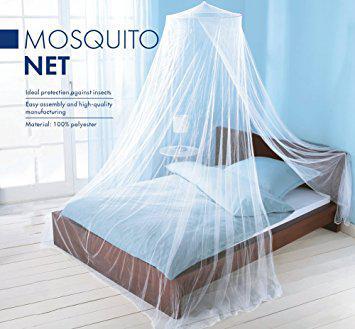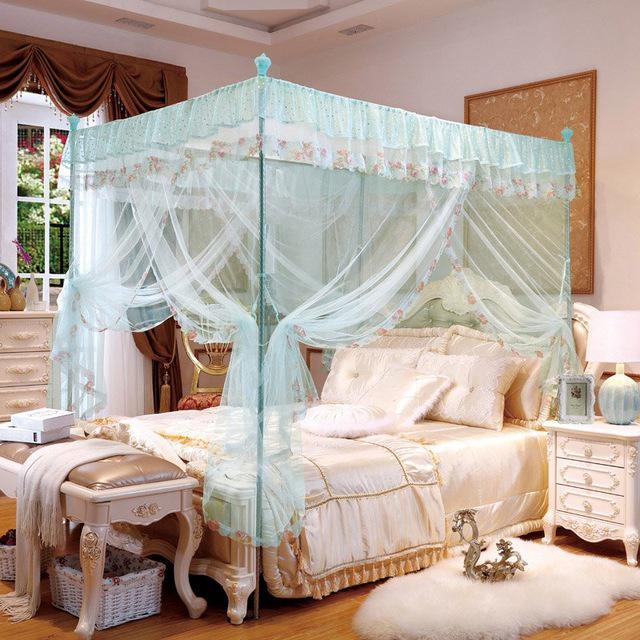The first image is the image on the left, the second image is the image on the right. Examine the images to the left and right. Is the description "The drapery of one bed frames it as a four poster with a top ruffle, while the other bed drapery falls from a central point above the bed." accurate? Answer yes or no. Yes. The first image is the image on the left, the second image is the image on the right. For the images shown, is this caption "An image shows a ceiling-suspended tent-shaped netting bed canopy." true? Answer yes or no. Yes. 